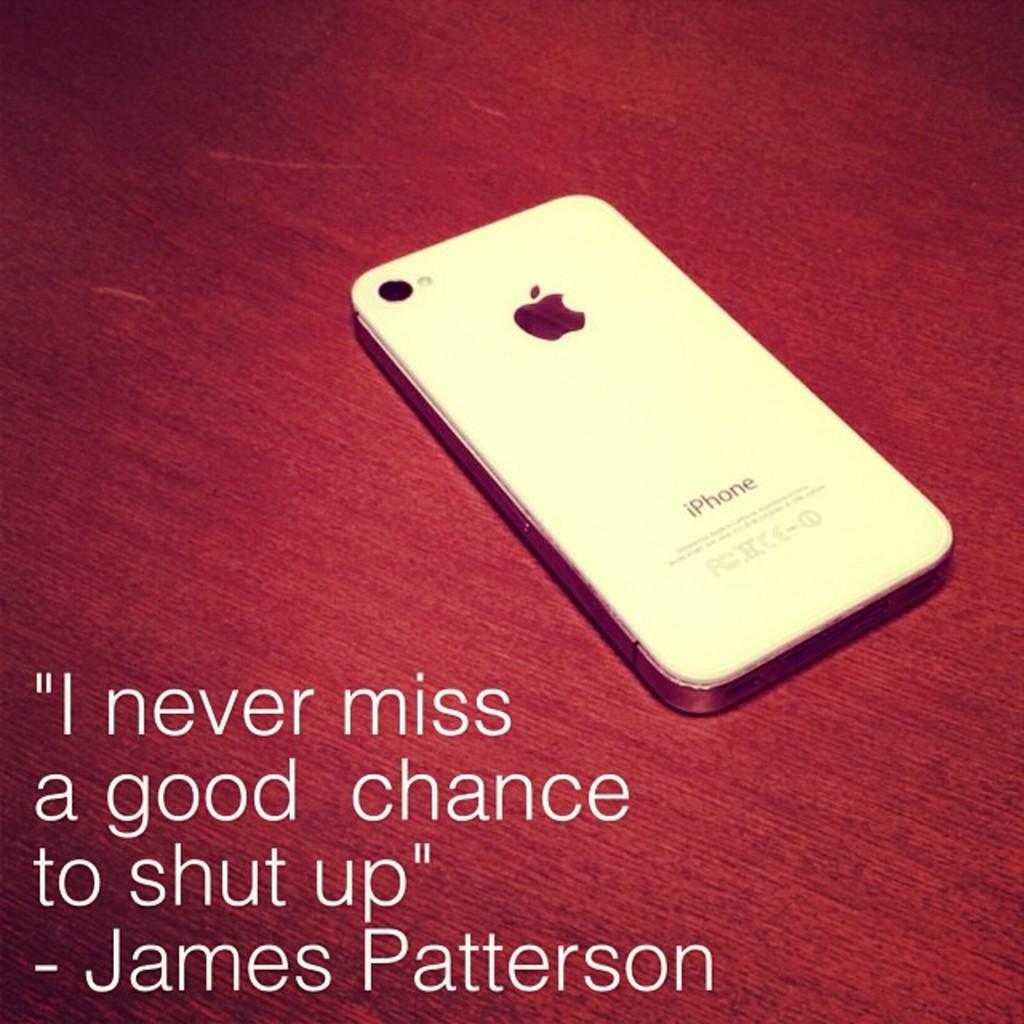Who said "i never miss a good chance to shut up"?
Keep it short and to the point. James patterson. What phone is displayed?
Keep it short and to the point. Iphone. 